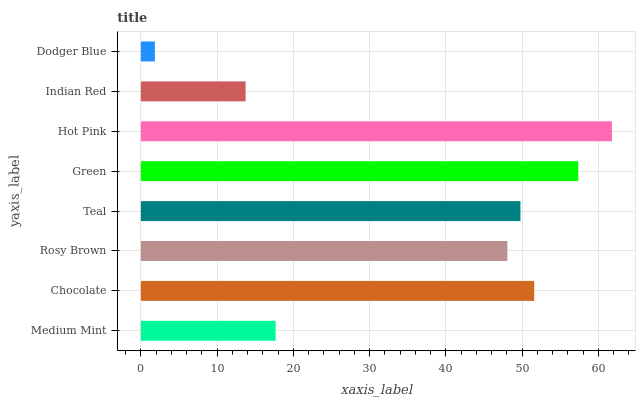Is Dodger Blue the minimum?
Answer yes or no. Yes. Is Hot Pink the maximum?
Answer yes or no. Yes. Is Chocolate the minimum?
Answer yes or no. No. Is Chocolate the maximum?
Answer yes or no. No. Is Chocolate greater than Medium Mint?
Answer yes or no. Yes. Is Medium Mint less than Chocolate?
Answer yes or no. Yes. Is Medium Mint greater than Chocolate?
Answer yes or no. No. Is Chocolate less than Medium Mint?
Answer yes or no. No. Is Teal the high median?
Answer yes or no. Yes. Is Rosy Brown the low median?
Answer yes or no. Yes. Is Hot Pink the high median?
Answer yes or no. No. Is Medium Mint the low median?
Answer yes or no. No. 